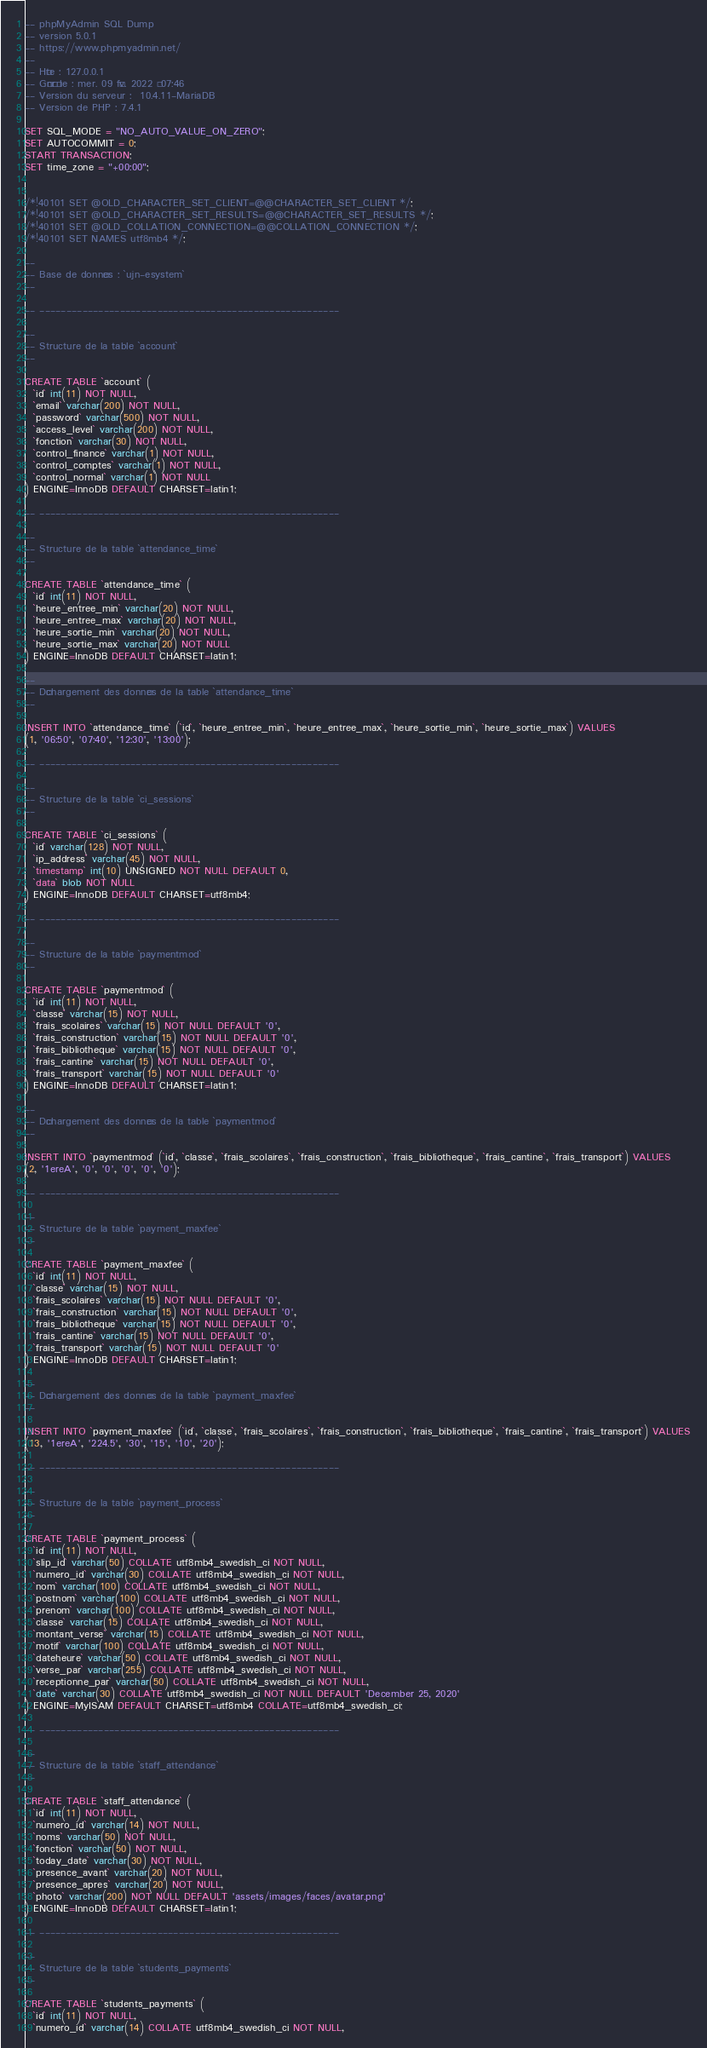<code> <loc_0><loc_0><loc_500><loc_500><_SQL_>-- phpMyAdmin SQL Dump
-- version 5.0.1
-- https://www.phpmyadmin.net/
--
-- Hôte : 127.0.0.1
-- Généré le : mer. 09 fév. 2022 à 07:46
-- Version du serveur :  10.4.11-MariaDB
-- Version de PHP : 7.4.1

SET SQL_MODE = "NO_AUTO_VALUE_ON_ZERO";
SET AUTOCOMMIT = 0;
START TRANSACTION;
SET time_zone = "+00:00";


/*!40101 SET @OLD_CHARACTER_SET_CLIENT=@@CHARACTER_SET_CLIENT */;
/*!40101 SET @OLD_CHARACTER_SET_RESULTS=@@CHARACTER_SET_RESULTS */;
/*!40101 SET @OLD_COLLATION_CONNECTION=@@COLLATION_CONNECTION */;
/*!40101 SET NAMES utf8mb4 */;

--
-- Base de données : `ujn-esystem`
--

-- --------------------------------------------------------

--
-- Structure de la table `account`
--

CREATE TABLE `account` (
  `id` int(11) NOT NULL,
  `email` varchar(200) NOT NULL,
  `password` varchar(500) NOT NULL,
  `access_level` varchar(200) NOT NULL,
  `fonction` varchar(30) NOT NULL,
  `control_finance` varchar(1) NOT NULL,
  `control_comptes` varchar(1) NOT NULL,
  `control_normal` varchar(1) NOT NULL
) ENGINE=InnoDB DEFAULT CHARSET=latin1;

-- --------------------------------------------------------

--
-- Structure de la table `attendance_time`
--

CREATE TABLE `attendance_time` (
  `id` int(11) NOT NULL,
  `heure_entree_min` varchar(20) NOT NULL,
  `heure_entree_max` varchar(20) NOT NULL,
  `heure_sortie_min` varchar(20) NOT NULL,
  `heure_sortie_max` varchar(20) NOT NULL
) ENGINE=InnoDB DEFAULT CHARSET=latin1;

--
-- Déchargement des données de la table `attendance_time`
--

INSERT INTO `attendance_time` (`id`, `heure_entree_min`, `heure_entree_max`, `heure_sortie_min`, `heure_sortie_max`) VALUES
(1, '06:50', '07:40', '12:30', '13:00');

-- --------------------------------------------------------

--
-- Structure de la table `ci_sessions`
--

CREATE TABLE `ci_sessions` (
  `id` varchar(128) NOT NULL,
  `ip_address` varchar(45) NOT NULL,
  `timestamp` int(10) UNSIGNED NOT NULL DEFAULT 0,
  `data` blob NOT NULL
) ENGINE=InnoDB DEFAULT CHARSET=utf8mb4;

-- --------------------------------------------------------

--
-- Structure de la table `paymentmod`
--

CREATE TABLE `paymentmod` (
  `id` int(11) NOT NULL,
  `classe` varchar(15) NOT NULL,
  `frais_scolaires` varchar(15) NOT NULL DEFAULT '0',
  `frais_construction` varchar(15) NOT NULL DEFAULT '0',
  `frais_bibliotheque` varchar(15) NOT NULL DEFAULT '0',
  `frais_cantine` varchar(15) NOT NULL DEFAULT '0',
  `frais_transport` varchar(15) NOT NULL DEFAULT '0'
) ENGINE=InnoDB DEFAULT CHARSET=latin1;

--
-- Déchargement des données de la table `paymentmod`
--

INSERT INTO `paymentmod` (`id`, `classe`, `frais_scolaires`, `frais_construction`, `frais_bibliotheque`, `frais_cantine`, `frais_transport`) VALUES
(2, '1ereA', '0', '0', '0', '0', '0');

-- --------------------------------------------------------

--
-- Structure de la table `payment_maxfee`
--

CREATE TABLE `payment_maxfee` (
  `id` int(11) NOT NULL,
  `classe` varchar(15) NOT NULL,
  `frais_scolaires` varchar(15) NOT NULL DEFAULT '0',
  `frais_construction` varchar(15) NOT NULL DEFAULT '0',
  `frais_bibliotheque` varchar(15) NOT NULL DEFAULT '0',
  `frais_cantine` varchar(15) NOT NULL DEFAULT '0',
  `frais_transport` varchar(15) NOT NULL DEFAULT '0'
) ENGINE=InnoDB DEFAULT CHARSET=latin1;

--
-- Déchargement des données de la table `payment_maxfee`
--

INSERT INTO `payment_maxfee` (`id`, `classe`, `frais_scolaires`, `frais_construction`, `frais_bibliotheque`, `frais_cantine`, `frais_transport`) VALUES
(13, '1ereA', '224.5', '30', '15', '10', '20');

-- --------------------------------------------------------

--
-- Structure de la table `payment_process`
--

CREATE TABLE `payment_process` (
  `id` int(11) NOT NULL,
  `slip_id` varchar(50) COLLATE utf8mb4_swedish_ci NOT NULL,
  `numero_id` varchar(30) COLLATE utf8mb4_swedish_ci NOT NULL,
  `nom` varchar(100) COLLATE utf8mb4_swedish_ci NOT NULL,
  `postnom` varchar(100) COLLATE utf8mb4_swedish_ci NOT NULL,
  `prenom` varchar(100) COLLATE utf8mb4_swedish_ci NOT NULL,
  `classe` varchar(15) COLLATE utf8mb4_swedish_ci NOT NULL,
  `montant_verse` varchar(15) COLLATE utf8mb4_swedish_ci NOT NULL,
  `motif` varchar(100) COLLATE utf8mb4_swedish_ci NOT NULL,
  `dateheure` varchar(50) COLLATE utf8mb4_swedish_ci NOT NULL,
  `verse_par` varchar(255) COLLATE utf8mb4_swedish_ci NOT NULL,
  `receptionne_par` varchar(50) COLLATE utf8mb4_swedish_ci NOT NULL,
  `date` varchar(30) COLLATE utf8mb4_swedish_ci NOT NULL DEFAULT 'December 25, 2020'
) ENGINE=MyISAM DEFAULT CHARSET=utf8mb4 COLLATE=utf8mb4_swedish_ci;

-- --------------------------------------------------------

--
-- Structure de la table `staff_attendance`
--

CREATE TABLE `staff_attendance` (
  `id` int(11) NOT NULL,
  `numero_id` varchar(14) NOT NULL,
  `noms` varchar(50) NOT NULL,
  `fonction` varchar(50) NOT NULL,
  `today_date` varchar(30) NOT NULL,
  `presence_avant` varchar(20) NOT NULL,
  `presence_apres` varchar(20) NOT NULL,
  `photo` varchar(200) NOT NULL DEFAULT 'assets/images/faces/avatar.png'
) ENGINE=InnoDB DEFAULT CHARSET=latin1;

-- --------------------------------------------------------

--
-- Structure de la table `students_payments`
--

CREATE TABLE `students_payments` (
  `id` int(11) NOT NULL,
  `numero_id` varchar(14) COLLATE utf8mb4_swedish_ci NOT NULL,</code> 